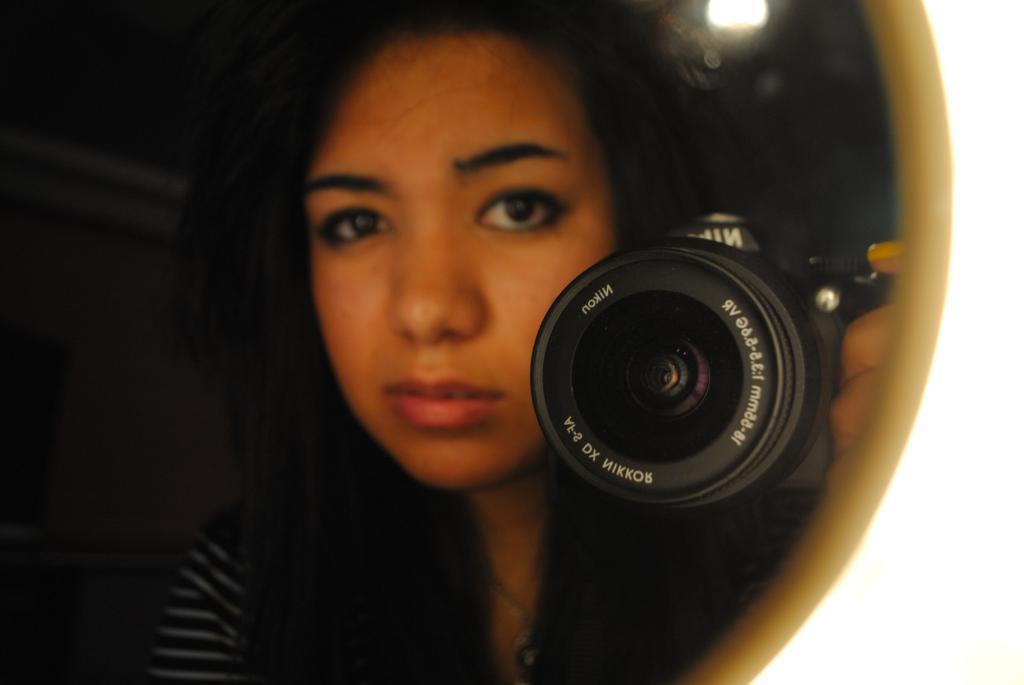Please provide a concise description of this image. In this image we can see a person holding camera and we can see a light and the dark background. 